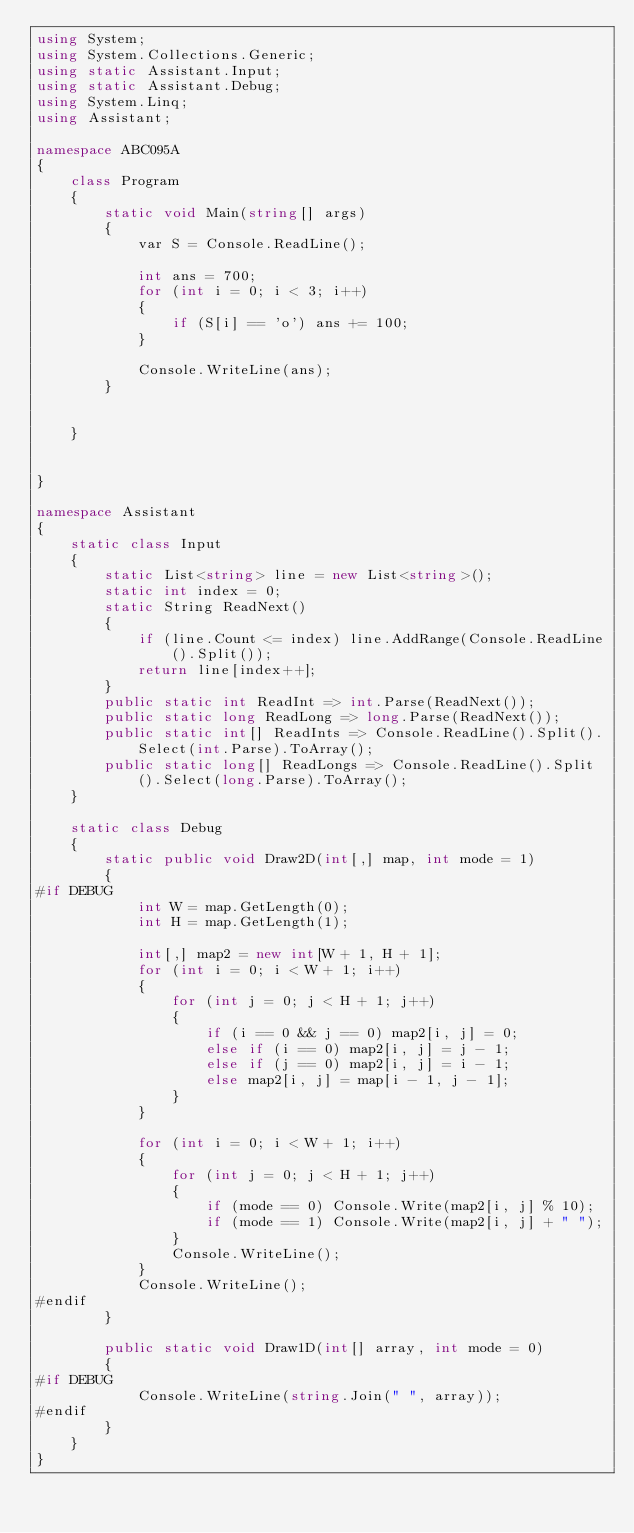<code> <loc_0><loc_0><loc_500><loc_500><_C#_>using System;
using System.Collections.Generic;
using static Assistant.Input;
using static Assistant.Debug;
using System.Linq;
using Assistant;

namespace ABC095A
{
    class Program
    {
        static void Main(string[] args)
        {
            var S = Console.ReadLine();

            int ans = 700;
            for (int i = 0; i < 3; i++)
            {
                if (S[i] == 'o') ans += 100;
            }

            Console.WriteLine(ans);
        }


    }


}

namespace Assistant
{
    static class Input
    {
        static List<string> line = new List<string>();
        static int index = 0;
        static String ReadNext()
        {
            if (line.Count <= index) line.AddRange(Console.ReadLine().Split());
            return line[index++];
        }
        public static int ReadInt => int.Parse(ReadNext());
        public static long ReadLong => long.Parse(ReadNext());
        public static int[] ReadInts => Console.ReadLine().Split().Select(int.Parse).ToArray();
        public static long[] ReadLongs => Console.ReadLine().Split().Select(long.Parse).ToArray();
    }

    static class Debug
    {
        static public void Draw2D(int[,] map, int mode = 1)
        {
#if DEBUG
            int W = map.GetLength(0);
            int H = map.GetLength(1);

            int[,] map2 = new int[W + 1, H + 1];
            for (int i = 0; i < W + 1; i++)
            {
                for (int j = 0; j < H + 1; j++)
                {
                    if (i == 0 && j == 0) map2[i, j] = 0;
                    else if (i == 0) map2[i, j] = j - 1;
                    else if (j == 0) map2[i, j] = i - 1;
                    else map2[i, j] = map[i - 1, j - 1];
                }
            }

            for (int i = 0; i < W + 1; i++)
            {
                for (int j = 0; j < H + 1; j++)
                {
                    if (mode == 0) Console.Write(map2[i, j] % 10);
                    if (mode == 1) Console.Write(map2[i, j] + " ");
                }
                Console.WriteLine();
            }
            Console.WriteLine();
#endif
        }

        public static void Draw1D(int[] array, int mode = 0)
        {
#if DEBUG
            Console.WriteLine(string.Join(" ", array));
#endif
        }
    }
}
</code> 